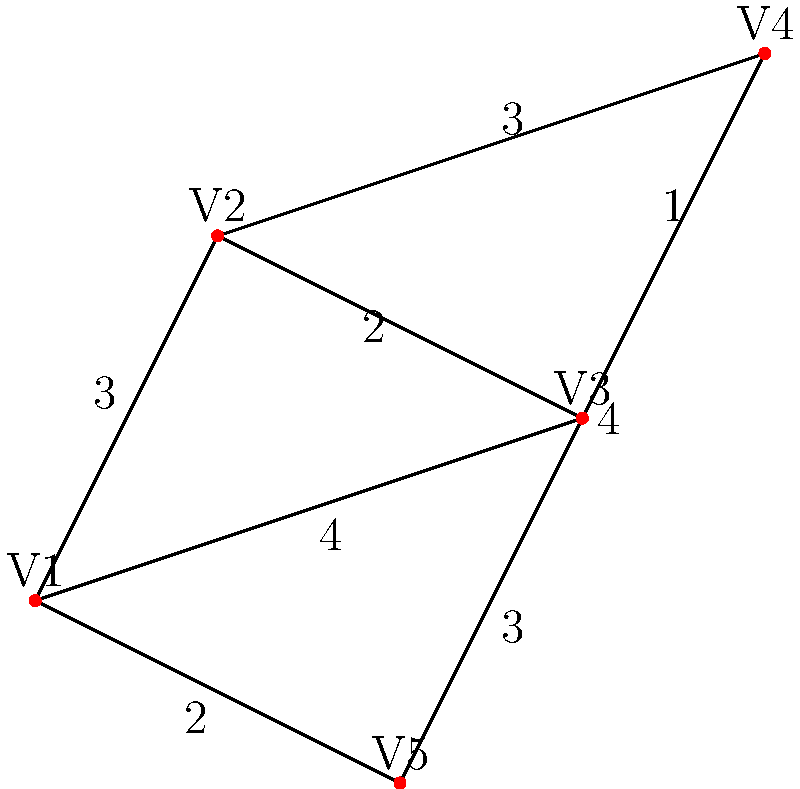Five tribal villages (V1, V2, V3, V4, and V5) are connected by paths as shown in the diagram. The numbers on the paths represent the distance between villages in hours of walking. What is the minimum total distance (in hours) required to connect all five villages with a network of paths? To find the minimum total distance required to connect all five villages, we need to find the Minimum Spanning Tree (MST) of the graph. We can use Kruskal's algorithm to solve this problem:

1. Sort all edges by weight (distance) in ascending order:
   (V2-V3, 1), (V1-V5, 2), (V1-V2, 3), (V2-V4, 3), (V2-V5, 3), (V1-V3, 4), (V3-V5, 4), (V4-V5, 4)

2. Start with an empty set of edges and add edges one by one:
   a. Add (V2-V3, 1)
   b. Add (V1-V5, 2)
   c. Add (V1-V2, 3)
   d. Add (V2-V4, 3)

3. Stop when we have added 4 edges (number of villages - 1)

4. The MST consists of the following edges:
   (V2-V3, 1), (V1-V5, 2), (V1-V2, 3), (V2-V4, 3)

5. Calculate the total distance:
   1 + 2 + 3 + 3 = 9 hours

Therefore, the minimum total distance required to connect all five villages is 9 hours of walking.
Answer: 9 hours 